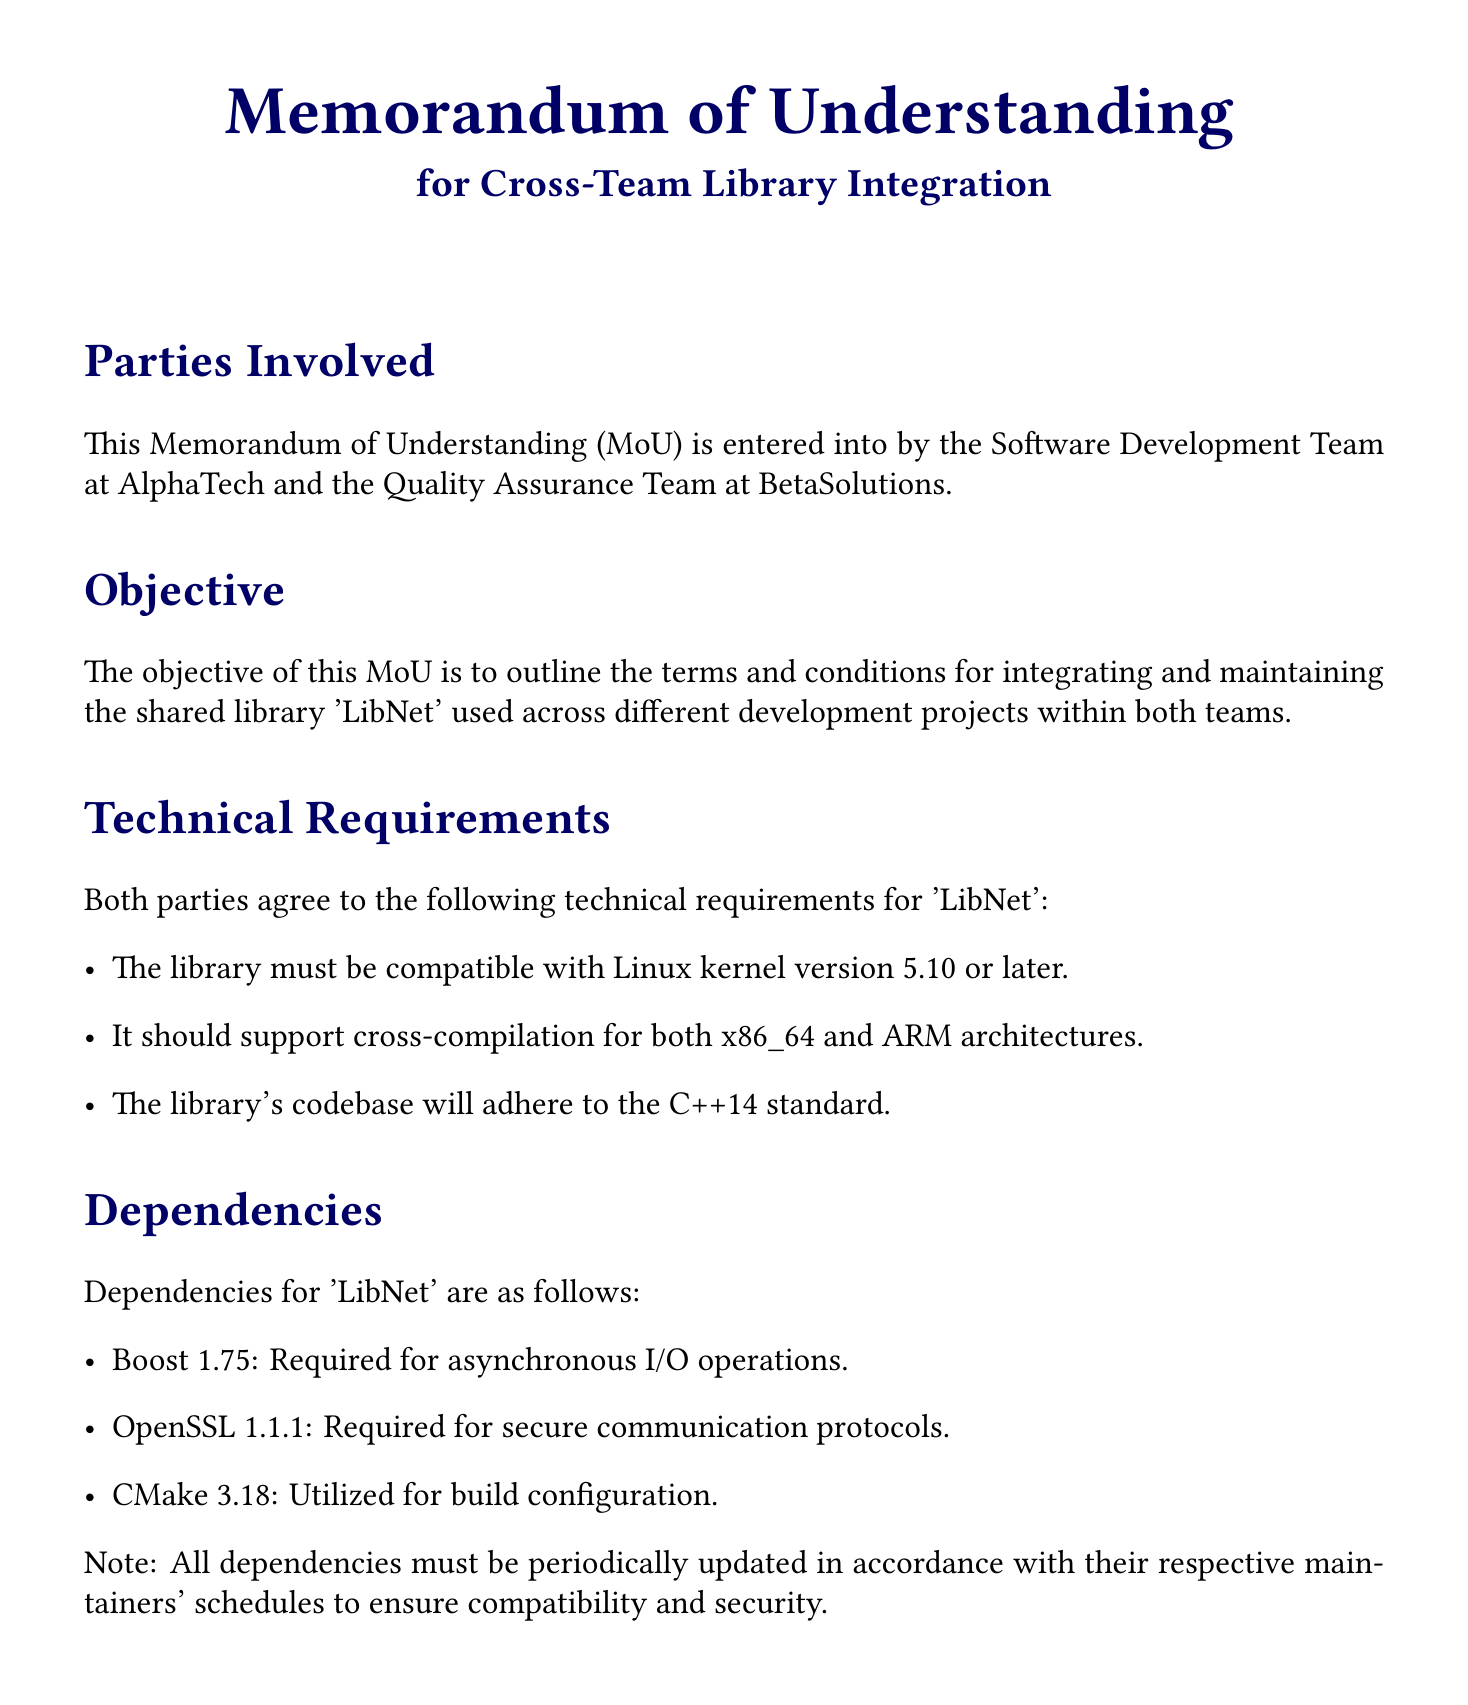What is the effective date of this Memorandum of Understanding? The document indicates that it was signed on 31 October 2023 by both parties.
Answer: 31 October 2023 Who is responsible for the initial development of 'LibNet'? According to the maintenance commitments, AlphaTech is responsible for the initial development of 'LibNet'.
Answer: AlphaTech What library standard must 'LibNet' adhere to? Per the technical requirements, the library's codebase should adhere to the C++14 standard.
Answer: C++14 Which team handles quality assurance testing? BetaSolutions is responsible for QA testing as stated in the maintenance commitments section.
Answer: BetaSolutions What will be the frequency of the joint meetings? The document specifies that a joint bi-weekly meeting will be scheduled to discuss progress and issues.
Answer: Bi-weekly What is the required version of OpenSSL for 'LibNet'? The dependencies section states that OpenSSL version 1.1.1 is required for the library.
Answer: 1.1.1 What kind of disputes resolution method is mentioned in the document? The document stipulates that any disputes will be resolved via arbitration.
Answer: Arbitration What is the primary objective of this MoU? The objective outlined is to integrate and maintain the shared library 'LibNet'.
Answer: Integrate and maintain 'LibNet' What is the Linux kernel version compatibility requirement for 'LibNet'? The document states that 'LibNet' must be compatible with Linux kernel version 5.10 or later.
Answer: 5.10 or later 